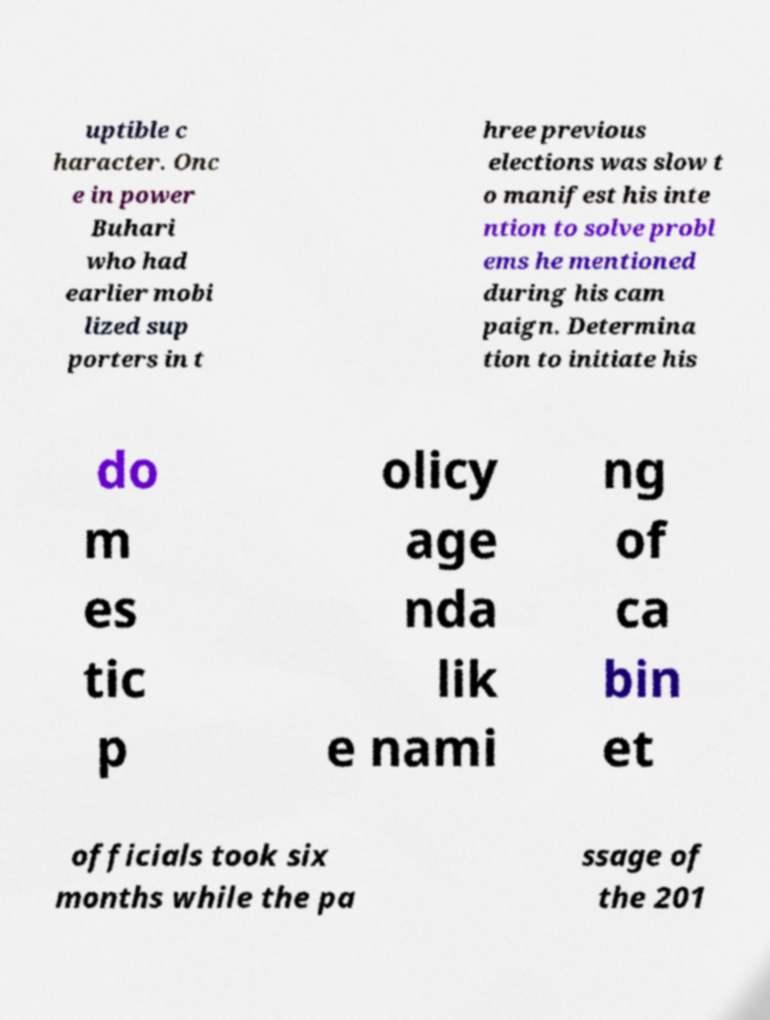I need the written content from this picture converted into text. Can you do that? uptible c haracter. Onc e in power Buhari who had earlier mobi lized sup porters in t hree previous elections was slow t o manifest his inte ntion to solve probl ems he mentioned during his cam paign. Determina tion to initiate his do m es tic p olicy age nda lik e nami ng of ca bin et officials took six months while the pa ssage of the 201 